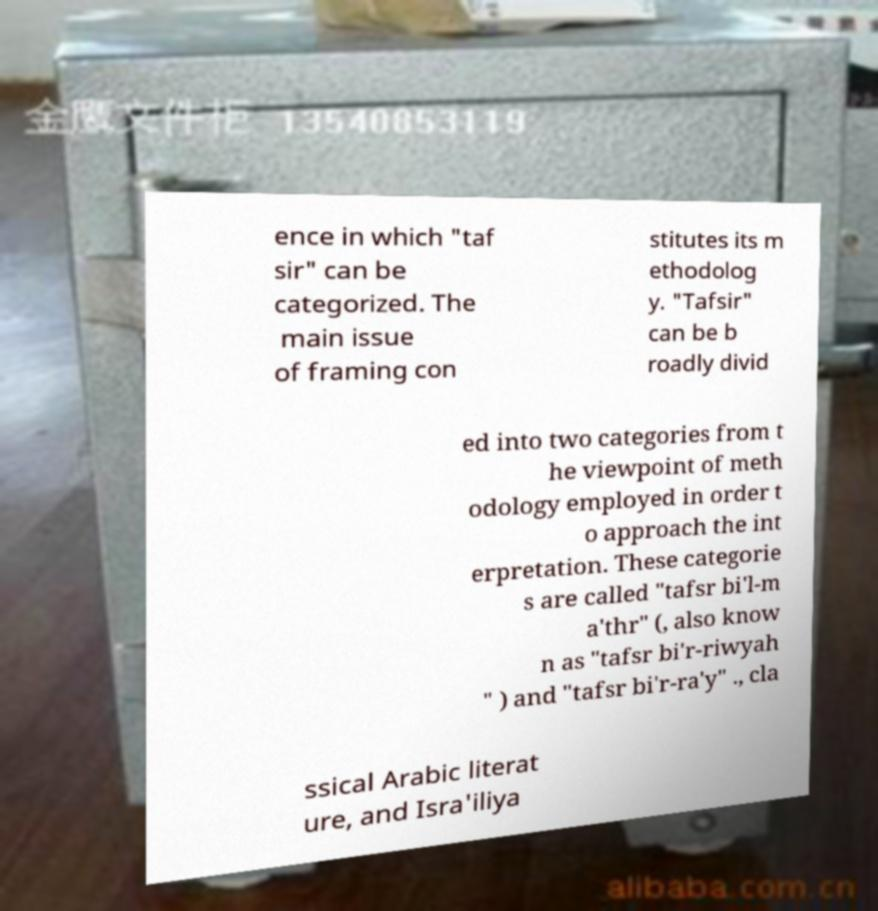For documentation purposes, I need the text within this image transcribed. Could you provide that? ence in which "taf sir" can be categorized. The main issue of framing con stitutes its m ethodolog y. "Tafsir" can be b roadly divid ed into two categories from t he viewpoint of meth odology employed in order t o approach the int erpretation. These categorie s are called "tafsr bi'l-m a'thr" (, also know n as "tafsr bi'r-riwyah " ) and "tafsr bi'r-ra'y" ., cla ssical Arabic literat ure, and Isra'iliya 